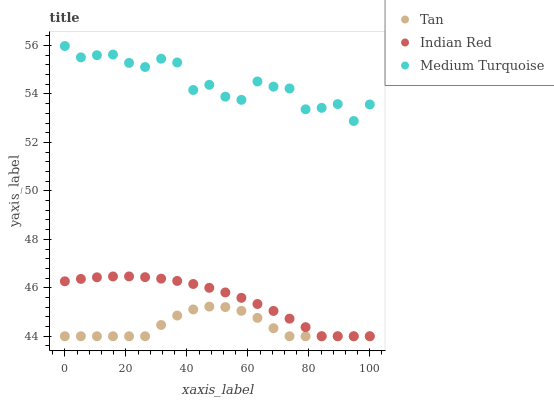Does Tan have the minimum area under the curve?
Answer yes or no. Yes. Does Medium Turquoise have the maximum area under the curve?
Answer yes or no. Yes. Does Indian Red have the minimum area under the curve?
Answer yes or no. No. Does Indian Red have the maximum area under the curve?
Answer yes or no. No. Is Indian Red the smoothest?
Answer yes or no. Yes. Is Medium Turquoise the roughest?
Answer yes or no. Yes. Is Medium Turquoise the smoothest?
Answer yes or no. No. Is Indian Red the roughest?
Answer yes or no. No. Does Tan have the lowest value?
Answer yes or no. Yes. Does Medium Turquoise have the lowest value?
Answer yes or no. No. Does Medium Turquoise have the highest value?
Answer yes or no. Yes. Does Indian Red have the highest value?
Answer yes or no. No. Is Indian Red less than Medium Turquoise?
Answer yes or no. Yes. Is Medium Turquoise greater than Tan?
Answer yes or no. Yes. Does Tan intersect Indian Red?
Answer yes or no. Yes. Is Tan less than Indian Red?
Answer yes or no. No. Is Tan greater than Indian Red?
Answer yes or no. No. Does Indian Red intersect Medium Turquoise?
Answer yes or no. No. 